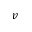<formula> <loc_0><loc_0><loc_500><loc_500>v</formula> 